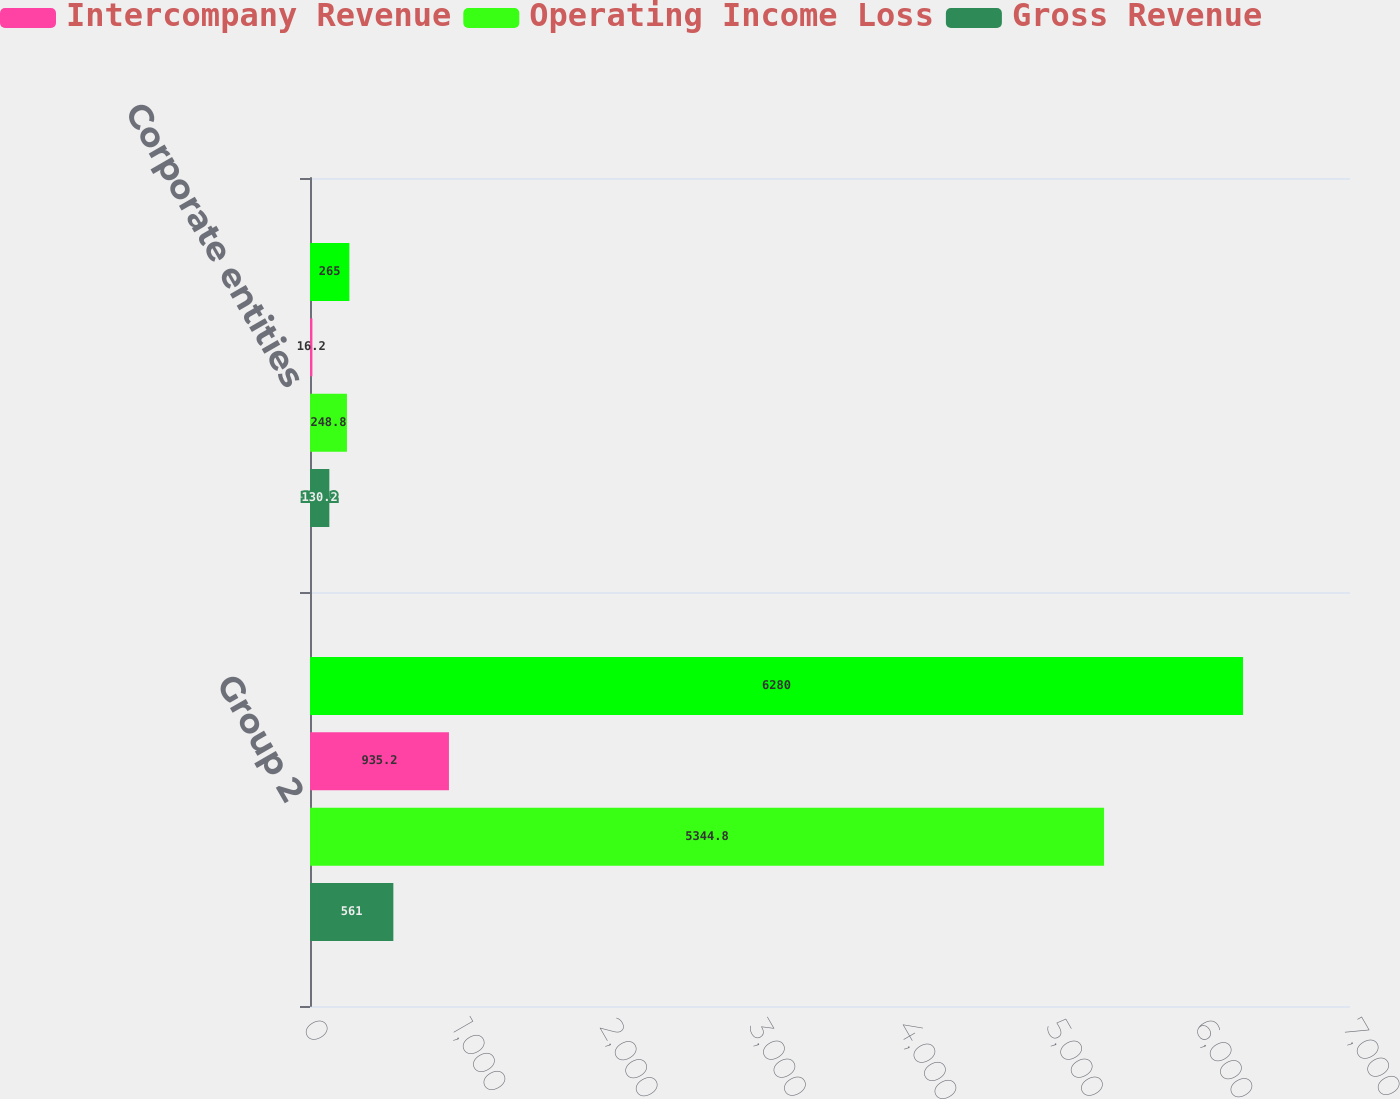Convert chart. <chart><loc_0><loc_0><loc_500><loc_500><stacked_bar_chart><ecel><fcel>Group 2<fcel>Corporate entities<nl><fcel>nan<fcel>6280<fcel>265<nl><fcel>Intercompany Revenue<fcel>935.2<fcel>16.2<nl><fcel>Operating Income Loss<fcel>5344.8<fcel>248.8<nl><fcel>Gross Revenue<fcel>561<fcel>130.2<nl></chart> 